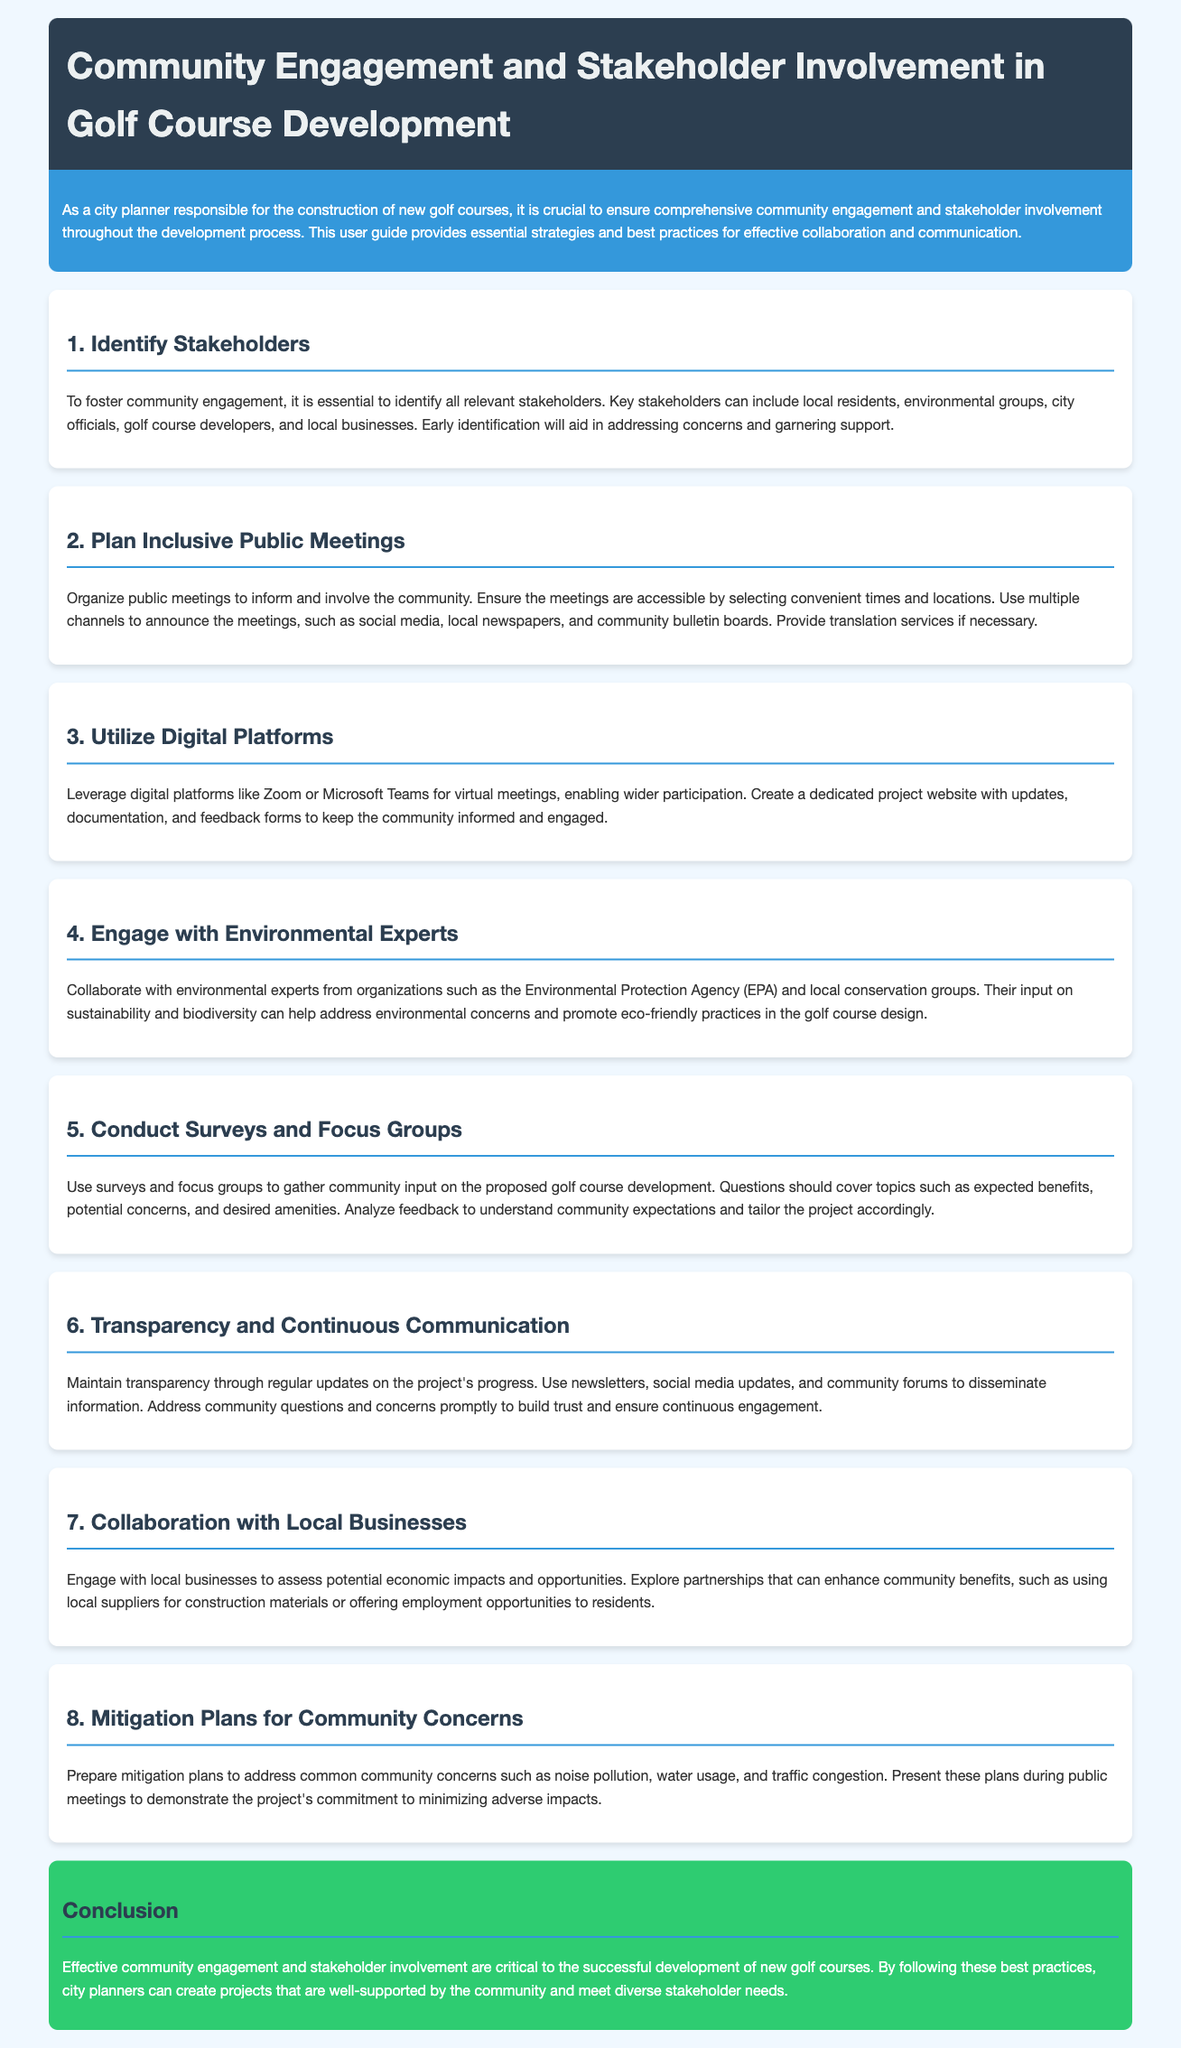What is the title of the document? The title of the document is found in the header section, which indicates the main topic being addressed.
Answer: Community Engagement and Stakeholder Involvement in Golf Course Development What are some of the key stakeholders mentioned? The document specifies various stakeholders in the section about identifying stakeholders, listing those relevant to the golf course development.
Answer: Local residents, environmental groups, city officials, golf course developers, local businesses How many main sections are there in the document? The number of sections can be counted by examining the section headings listed in the document.
Answer: 8 What platform is suggested for virtual meetings? The document provides examples of digital platforms that can be used for meetings.
Answer: Zoom or Microsoft Teams What is one method suggested for gathering community input? The document outlines specific methods for collecting feedback from the community.
Answer: Surveys and focus groups What should be included in the mitigation plans? The mitigation plans aim to address specific community concerns mentioned in the relevant section of the document.
Answer: Noise pollution, water usage, traffic congestion What is a recommended way to maintain project transparency? The document discusses strategies for keeping the community informed throughout the development process.
Answer: Regular updates What type of partnership should be explored with local businesses? The document suggests economic collaborations that can enhance community benefits within the discussions of local business engagement.
Answer: Using local suppliers 